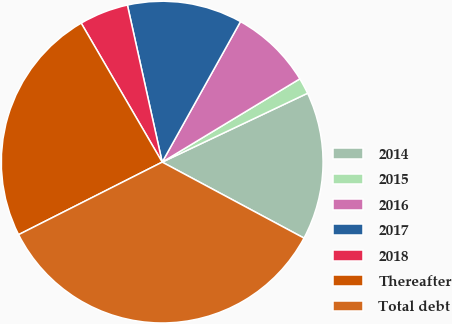Convert chart to OTSL. <chart><loc_0><loc_0><loc_500><loc_500><pie_chart><fcel>2014<fcel>2015<fcel>2016<fcel>2017<fcel>2018<fcel>Thereafter<fcel>Total debt<nl><fcel>14.87%<fcel>1.62%<fcel>8.25%<fcel>11.56%<fcel>4.93%<fcel>24.05%<fcel>34.73%<nl></chart> 